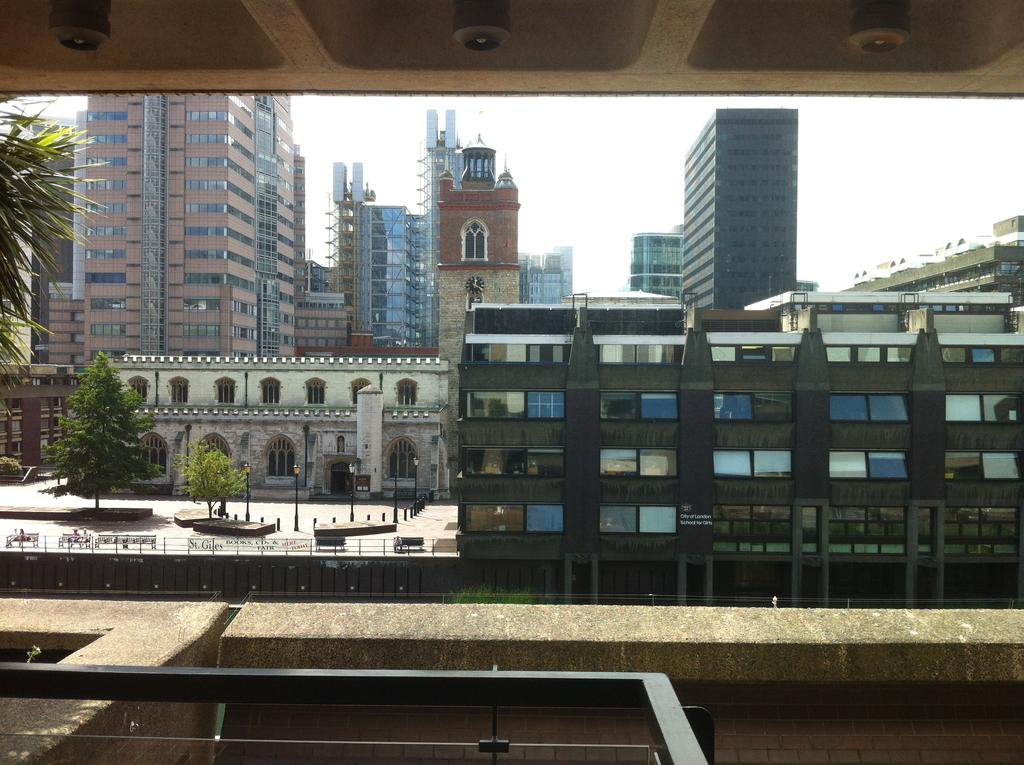What type of structures can be seen in the image? There are buildings with windows in the image. What other natural elements are present in the image? There are trees in the image. What type of infrastructure is present in the image? Electric poles with lights are present in the image. What type of barrier can be seen in the image? Fences are visible in the image. What are the people in the image doing? The people sitting on benches in the image. What can be seen in the background of the image? The sky is visible in the background of the image. Can you tell me how many berries are on the electric poles in the image? There are no berries present on the electric poles in the image. What type of crayon is being used by the people sitting on the benches in the image? There are no crayons present in the image, and the people sitting on the benches are not using any. 